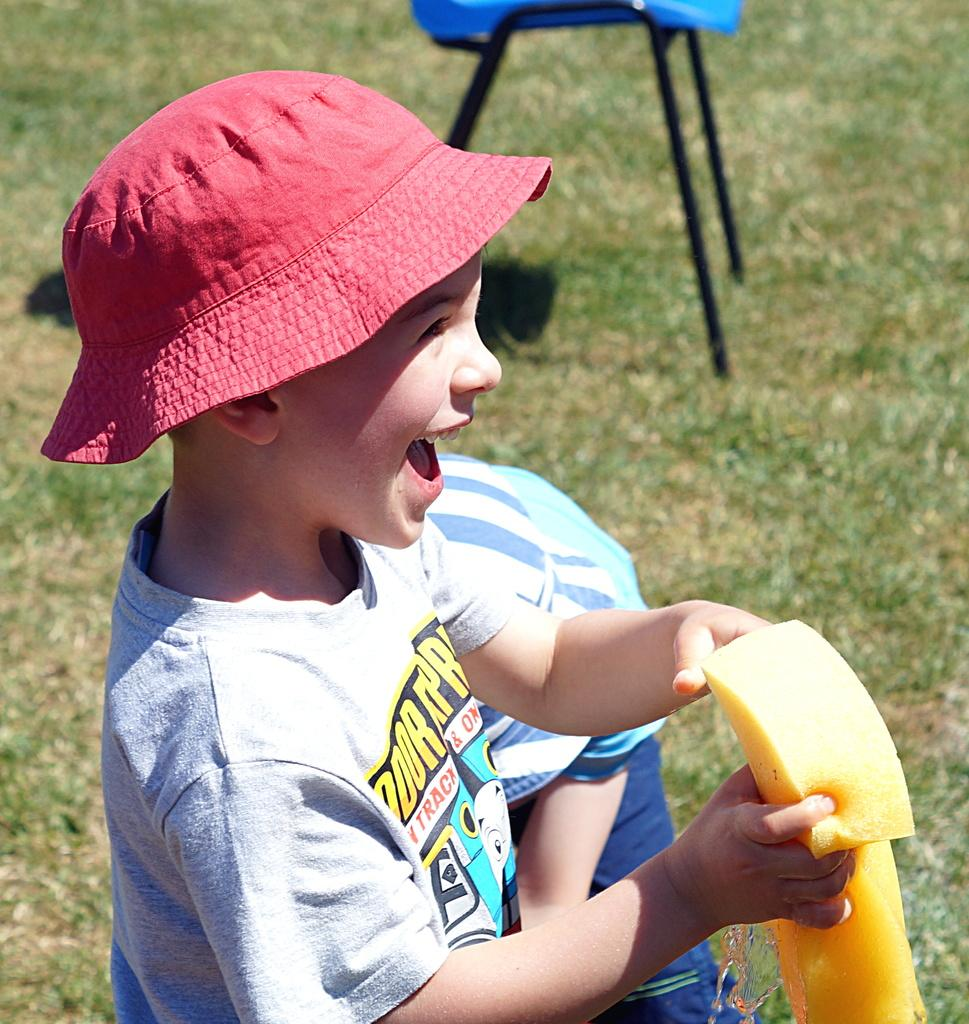Who is present in the image? There are people in the image. Can you describe the boy in the image? The boy is wearing a cap. What is the boy holding in the image? The boy is holding a sponge. What can be seen in the background of the image? There is a chair in the background of the image. What type of seed is the boy planting in the image? There is no seed or planting activity depicted in the image; the boy is holding a sponge. What fact can be learned about the boy from the image? The image provides information about the boy's appearance (wearing a cap) and what he is holding (a sponge), but it does not convey any specific facts about him. 